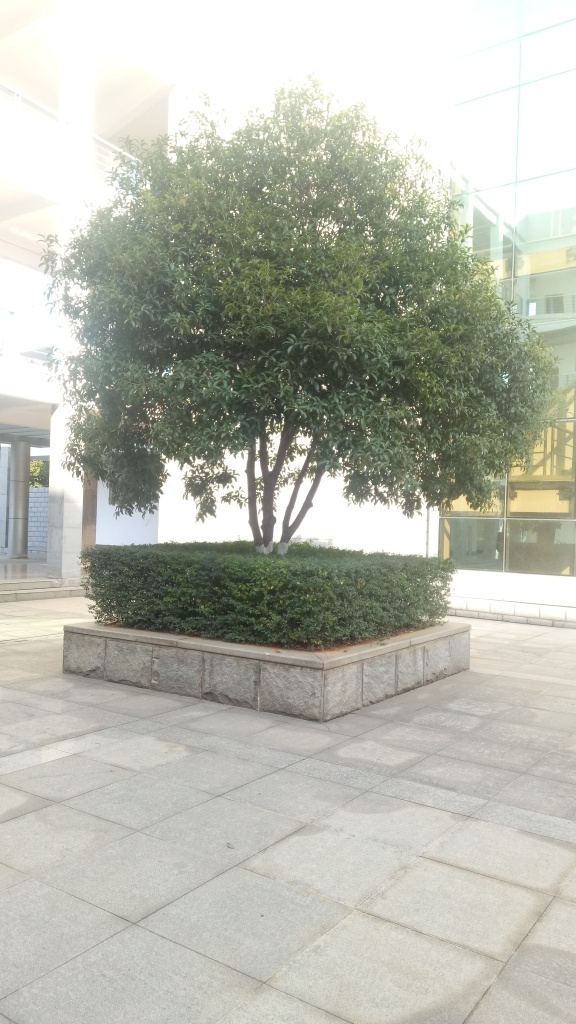What time of day does this photo seem to have been taken? Based on the long shadows and the warm glow, it appears to have been taken in the early morning or late afternoon, during the 'golden hour' of photography. The soft light enhances the texture of the leaves and adds a peaceful mood to the scene. Could you suggest any improvements to the composition? To improve the composition, the photographer could experiment with the rule of thirds to add dynamism by placing the tree off-center. Additionally, varying the angle or introducing a foreground subject could create depth and interest. 